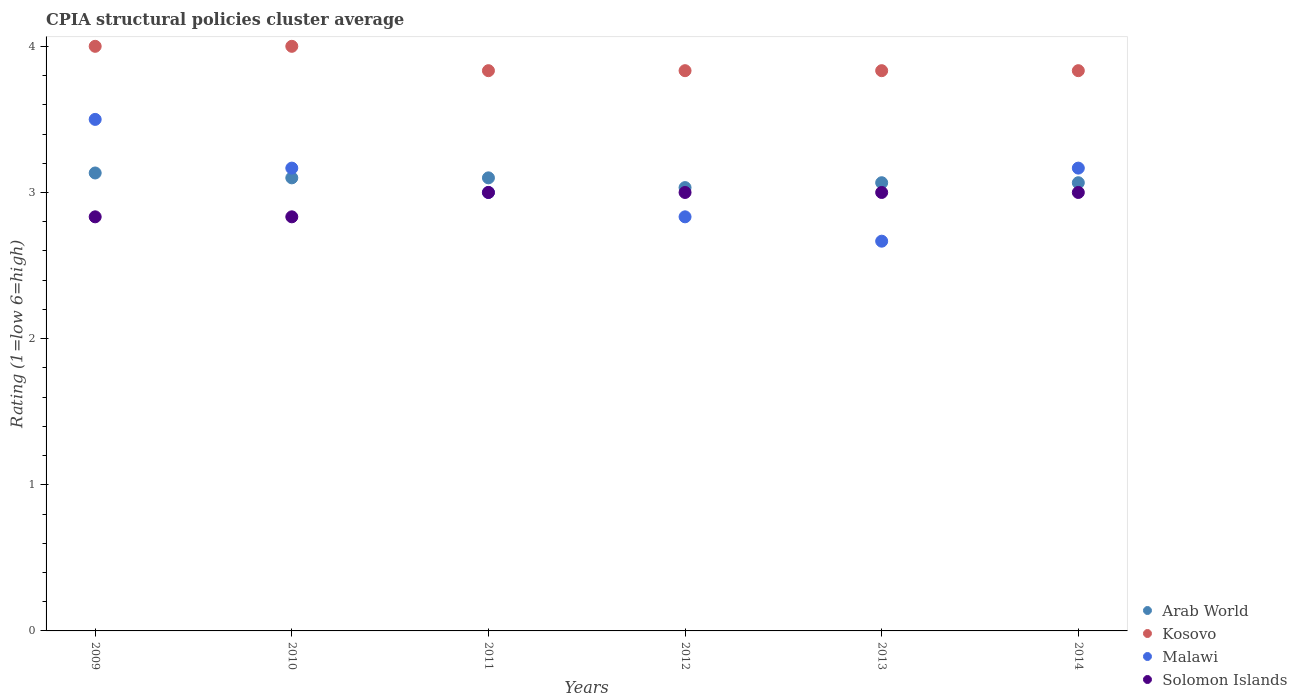How many different coloured dotlines are there?
Provide a short and direct response. 4. What is the CPIA rating in Malawi in 2013?
Make the answer very short. 2.67. Across all years, what is the maximum CPIA rating in Arab World?
Your answer should be compact. 3.13. Across all years, what is the minimum CPIA rating in Solomon Islands?
Your response must be concise. 2.83. In which year was the CPIA rating in Kosovo minimum?
Offer a terse response. 2014. What is the total CPIA rating in Solomon Islands in the graph?
Provide a succinct answer. 17.67. What is the difference between the CPIA rating in Malawi in 2010 and that in 2012?
Your answer should be compact. 0.33. What is the average CPIA rating in Kosovo per year?
Your answer should be very brief. 3.89. In how many years, is the CPIA rating in Kosovo greater than 2.6?
Make the answer very short. 6. What is the ratio of the CPIA rating in Malawi in 2011 to that in 2013?
Ensure brevity in your answer.  1.12. Is the difference between the CPIA rating in Malawi in 2010 and 2011 greater than the difference between the CPIA rating in Kosovo in 2010 and 2011?
Provide a succinct answer. No. What is the difference between the highest and the second highest CPIA rating in Kosovo?
Your answer should be very brief. 0. What is the difference between the highest and the lowest CPIA rating in Malawi?
Your response must be concise. 0.83. In how many years, is the CPIA rating in Malawi greater than the average CPIA rating in Malawi taken over all years?
Your answer should be very brief. 3. Is the sum of the CPIA rating in Malawi in 2010 and 2011 greater than the maximum CPIA rating in Kosovo across all years?
Your answer should be very brief. Yes. Is it the case that in every year, the sum of the CPIA rating in Arab World and CPIA rating in Malawi  is greater than the CPIA rating in Solomon Islands?
Offer a very short reply. Yes. Does the CPIA rating in Malawi monotonically increase over the years?
Offer a terse response. No. Is the CPIA rating in Malawi strictly greater than the CPIA rating in Kosovo over the years?
Provide a short and direct response. No. How many dotlines are there?
Your answer should be compact. 4. How many years are there in the graph?
Keep it short and to the point. 6. Are the values on the major ticks of Y-axis written in scientific E-notation?
Your response must be concise. No. Does the graph contain any zero values?
Keep it short and to the point. No. Does the graph contain grids?
Offer a very short reply. No. Where does the legend appear in the graph?
Your response must be concise. Bottom right. How are the legend labels stacked?
Ensure brevity in your answer.  Vertical. What is the title of the graph?
Your answer should be very brief. CPIA structural policies cluster average. Does "Dominica" appear as one of the legend labels in the graph?
Your response must be concise. No. What is the Rating (1=low 6=high) in Arab World in 2009?
Provide a succinct answer. 3.13. What is the Rating (1=low 6=high) of Solomon Islands in 2009?
Your answer should be very brief. 2.83. What is the Rating (1=low 6=high) in Arab World in 2010?
Keep it short and to the point. 3.1. What is the Rating (1=low 6=high) of Kosovo in 2010?
Ensure brevity in your answer.  4. What is the Rating (1=low 6=high) in Malawi in 2010?
Your response must be concise. 3.17. What is the Rating (1=low 6=high) in Solomon Islands in 2010?
Your response must be concise. 2.83. What is the Rating (1=low 6=high) in Kosovo in 2011?
Offer a terse response. 3.83. What is the Rating (1=low 6=high) of Malawi in 2011?
Ensure brevity in your answer.  3. What is the Rating (1=low 6=high) in Solomon Islands in 2011?
Provide a short and direct response. 3. What is the Rating (1=low 6=high) of Arab World in 2012?
Give a very brief answer. 3.03. What is the Rating (1=low 6=high) of Kosovo in 2012?
Make the answer very short. 3.83. What is the Rating (1=low 6=high) of Malawi in 2012?
Give a very brief answer. 2.83. What is the Rating (1=low 6=high) in Arab World in 2013?
Provide a short and direct response. 3.07. What is the Rating (1=low 6=high) of Kosovo in 2013?
Your answer should be very brief. 3.83. What is the Rating (1=low 6=high) in Malawi in 2013?
Your answer should be compact. 2.67. What is the Rating (1=low 6=high) of Solomon Islands in 2013?
Your answer should be compact. 3. What is the Rating (1=low 6=high) in Arab World in 2014?
Your answer should be very brief. 3.07. What is the Rating (1=low 6=high) in Kosovo in 2014?
Your response must be concise. 3.83. What is the Rating (1=low 6=high) of Malawi in 2014?
Your answer should be compact. 3.17. Across all years, what is the maximum Rating (1=low 6=high) of Arab World?
Offer a terse response. 3.13. Across all years, what is the minimum Rating (1=low 6=high) in Arab World?
Give a very brief answer. 3.03. Across all years, what is the minimum Rating (1=low 6=high) in Kosovo?
Your answer should be compact. 3.83. Across all years, what is the minimum Rating (1=low 6=high) of Malawi?
Ensure brevity in your answer.  2.67. Across all years, what is the minimum Rating (1=low 6=high) of Solomon Islands?
Provide a short and direct response. 2.83. What is the total Rating (1=low 6=high) of Arab World in the graph?
Your answer should be very brief. 18.5. What is the total Rating (1=low 6=high) in Kosovo in the graph?
Your answer should be very brief. 23.33. What is the total Rating (1=low 6=high) in Malawi in the graph?
Ensure brevity in your answer.  18.33. What is the total Rating (1=low 6=high) of Solomon Islands in the graph?
Keep it short and to the point. 17.67. What is the difference between the Rating (1=low 6=high) in Kosovo in 2009 and that in 2010?
Offer a terse response. 0. What is the difference between the Rating (1=low 6=high) in Malawi in 2009 and that in 2010?
Offer a terse response. 0.33. What is the difference between the Rating (1=low 6=high) in Solomon Islands in 2009 and that in 2010?
Provide a short and direct response. 0. What is the difference between the Rating (1=low 6=high) of Kosovo in 2009 and that in 2012?
Keep it short and to the point. 0.17. What is the difference between the Rating (1=low 6=high) of Malawi in 2009 and that in 2012?
Your answer should be compact. 0.67. What is the difference between the Rating (1=low 6=high) of Arab World in 2009 and that in 2013?
Your response must be concise. 0.07. What is the difference between the Rating (1=low 6=high) of Malawi in 2009 and that in 2013?
Provide a short and direct response. 0.83. What is the difference between the Rating (1=low 6=high) of Arab World in 2009 and that in 2014?
Keep it short and to the point. 0.07. What is the difference between the Rating (1=low 6=high) in Kosovo in 2009 and that in 2014?
Offer a terse response. 0.17. What is the difference between the Rating (1=low 6=high) of Solomon Islands in 2009 and that in 2014?
Your response must be concise. -0.17. What is the difference between the Rating (1=low 6=high) of Kosovo in 2010 and that in 2011?
Provide a short and direct response. 0.17. What is the difference between the Rating (1=low 6=high) in Malawi in 2010 and that in 2011?
Offer a very short reply. 0.17. What is the difference between the Rating (1=low 6=high) of Arab World in 2010 and that in 2012?
Your answer should be compact. 0.07. What is the difference between the Rating (1=low 6=high) of Malawi in 2010 and that in 2012?
Ensure brevity in your answer.  0.33. What is the difference between the Rating (1=low 6=high) of Solomon Islands in 2010 and that in 2012?
Ensure brevity in your answer.  -0.17. What is the difference between the Rating (1=low 6=high) in Arab World in 2010 and that in 2013?
Keep it short and to the point. 0.03. What is the difference between the Rating (1=low 6=high) in Solomon Islands in 2010 and that in 2013?
Offer a very short reply. -0.17. What is the difference between the Rating (1=low 6=high) in Malawi in 2010 and that in 2014?
Provide a succinct answer. -0. What is the difference between the Rating (1=low 6=high) of Solomon Islands in 2010 and that in 2014?
Offer a terse response. -0.17. What is the difference between the Rating (1=low 6=high) of Arab World in 2011 and that in 2012?
Your answer should be very brief. 0.07. What is the difference between the Rating (1=low 6=high) of Kosovo in 2011 and that in 2012?
Your answer should be compact. 0. What is the difference between the Rating (1=low 6=high) in Solomon Islands in 2011 and that in 2012?
Your answer should be compact. 0. What is the difference between the Rating (1=low 6=high) of Arab World in 2011 and that in 2013?
Your answer should be very brief. 0.03. What is the difference between the Rating (1=low 6=high) of Kosovo in 2011 and that in 2013?
Offer a very short reply. 0. What is the difference between the Rating (1=low 6=high) of Malawi in 2011 and that in 2013?
Give a very brief answer. 0.33. What is the difference between the Rating (1=low 6=high) of Solomon Islands in 2011 and that in 2013?
Provide a succinct answer. 0. What is the difference between the Rating (1=low 6=high) of Kosovo in 2011 and that in 2014?
Provide a short and direct response. 0. What is the difference between the Rating (1=low 6=high) of Arab World in 2012 and that in 2013?
Your answer should be compact. -0.03. What is the difference between the Rating (1=low 6=high) in Kosovo in 2012 and that in 2013?
Offer a terse response. 0. What is the difference between the Rating (1=low 6=high) in Malawi in 2012 and that in 2013?
Provide a short and direct response. 0.17. What is the difference between the Rating (1=low 6=high) of Arab World in 2012 and that in 2014?
Ensure brevity in your answer.  -0.03. What is the difference between the Rating (1=low 6=high) in Malawi in 2012 and that in 2014?
Offer a very short reply. -0.33. What is the difference between the Rating (1=low 6=high) in Arab World in 2013 and that in 2014?
Offer a very short reply. -0. What is the difference between the Rating (1=low 6=high) of Kosovo in 2013 and that in 2014?
Your answer should be very brief. 0. What is the difference between the Rating (1=low 6=high) in Solomon Islands in 2013 and that in 2014?
Ensure brevity in your answer.  0. What is the difference between the Rating (1=low 6=high) in Arab World in 2009 and the Rating (1=low 6=high) in Kosovo in 2010?
Your answer should be compact. -0.87. What is the difference between the Rating (1=low 6=high) in Arab World in 2009 and the Rating (1=low 6=high) in Malawi in 2010?
Make the answer very short. -0.03. What is the difference between the Rating (1=low 6=high) of Arab World in 2009 and the Rating (1=low 6=high) of Solomon Islands in 2010?
Keep it short and to the point. 0.3. What is the difference between the Rating (1=low 6=high) of Kosovo in 2009 and the Rating (1=low 6=high) of Solomon Islands in 2010?
Offer a very short reply. 1.17. What is the difference between the Rating (1=low 6=high) in Malawi in 2009 and the Rating (1=low 6=high) in Solomon Islands in 2010?
Provide a succinct answer. 0.67. What is the difference between the Rating (1=low 6=high) in Arab World in 2009 and the Rating (1=low 6=high) in Malawi in 2011?
Your answer should be compact. 0.13. What is the difference between the Rating (1=low 6=high) of Arab World in 2009 and the Rating (1=low 6=high) of Solomon Islands in 2011?
Offer a terse response. 0.13. What is the difference between the Rating (1=low 6=high) in Kosovo in 2009 and the Rating (1=low 6=high) in Malawi in 2011?
Make the answer very short. 1. What is the difference between the Rating (1=low 6=high) in Malawi in 2009 and the Rating (1=low 6=high) in Solomon Islands in 2011?
Provide a short and direct response. 0.5. What is the difference between the Rating (1=low 6=high) in Arab World in 2009 and the Rating (1=low 6=high) in Kosovo in 2012?
Ensure brevity in your answer.  -0.7. What is the difference between the Rating (1=low 6=high) in Arab World in 2009 and the Rating (1=low 6=high) in Malawi in 2012?
Provide a succinct answer. 0.3. What is the difference between the Rating (1=low 6=high) in Arab World in 2009 and the Rating (1=low 6=high) in Solomon Islands in 2012?
Provide a short and direct response. 0.13. What is the difference between the Rating (1=low 6=high) in Malawi in 2009 and the Rating (1=low 6=high) in Solomon Islands in 2012?
Your answer should be compact. 0.5. What is the difference between the Rating (1=low 6=high) of Arab World in 2009 and the Rating (1=low 6=high) of Kosovo in 2013?
Offer a terse response. -0.7. What is the difference between the Rating (1=low 6=high) of Arab World in 2009 and the Rating (1=low 6=high) of Malawi in 2013?
Your answer should be compact. 0.47. What is the difference between the Rating (1=low 6=high) in Arab World in 2009 and the Rating (1=low 6=high) in Solomon Islands in 2013?
Provide a succinct answer. 0.13. What is the difference between the Rating (1=low 6=high) of Kosovo in 2009 and the Rating (1=low 6=high) of Solomon Islands in 2013?
Your answer should be very brief. 1. What is the difference between the Rating (1=low 6=high) in Arab World in 2009 and the Rating (1=low 6=high) in Kosovo in 2014?
Your answer should be compact. -0.7. What is the difference between the Rating (1=low 6=high) in Arab World in 2009 and the Rating (1=low 6=high) in Malawi in 2014?
Ensure brevity in your answer.  -0.03. What is the difference between the Rating (1=low 6=high) of Arab World in 2009 and the Rating (1=low 6=high) of Solomon Islands in 2014?
Keep it short and to the point. 0.13. What is the difference between the Rating (1=low 6=high) of Kosovo in 2009 and the Rating (1=low 6=high) of Malawi in 2014?
Your response must be concise. 0.83. What is the difference between the Rating (1=low 6=high) of Kosovo in 2009 and the Rating (1=low 6=high) of Solomon Islands in 2014?
Your answer should be very brief. 1. What is the difference between the Rating (1=low 6=high) in Malawi in 2009 and the Rating (1=low 6=high) in Solomon Islands in 2014?
Your answer should be very brief. 0.5. What is the difference between the Rating (1=low 6=high) in Arab World in 2010 and the Rating (1=low 6=high) in Kosovo in 2011?
Offer a very short reply. -0.73. What is the difference between the Rating (1=low 6=high) in Arab World in 2010 and the Rating (1=low 6=high) in Kosovo in 2012?
Your answer should be compact. -0.73. What is the difference between the Rating (1=low 6=high) of Arab World in 2010 and the Rating (1=low 6=high) of Malawi in 2012?
Make the answer very short. 0.27. What is the difference between the Rating (1=low 6=high) of Kosovo in 2010 and the Rating (1=low 6=high) of Malawi in 2012?
Make the answer very short. 1.17. What is the difference between the Rating (1=low 6=high) of Kosovo in 2010 and the Rating (1=low 6=high) of Solomon Islands in 2012?
Offer a very short reply. 1. What is the difference between the Rating (1=low 6=high) in Arab World in 2010 and the Rating (1=low 6=high) in Kosovo in 2013?
Your response must be concise. -0.73. What is the difference between the Rating (1=low 6=high) of Arab World in 2010 and the Rating (1=low 6=high) of Malawi in 2013?
Your response must be concise. 0.43. What is the difference between the Rating (1=low 6=high) in Kosovo in 2010 and the Rating (1=low 6=high) in Solomon Islands in 2013?
Keep it short and to the point. 1. What is the difference between the Rating (1=low 6=high) of Arab World in 2010 and the Rating (1=low 6=high) of Kosovo in 2014?
Give a very brief answer. -0.73. What is the difference between the Rating (1=low 6=high) of Arab World in 2010 and the Rating (1=low 6=high) of Malawi in 2014?
Your answer should be very brief. -0.07. What is the difference between the Rating (1=low 6=high) of Kosovo in 2010 and the Rating (1=low 6=high) of Malawi in 2014?
Provide a succinct answer. 0.83. What is the difference between the Rating (1=low 6=high) of Malawi in 2010 and the Rating (1=low 6=high) of Solomon Islands in 2014?
Your response must be concise. 0.17. What is the difference between the Rating (1=low 6=high) in Arab World in 2011 and the Rating (1=low 6=high) in Kosovo in 2012?
Offer a terse response. -0.73. What is the difference between the Rating (1=low 6=high) of Arab World in 2011 and the Rating (1=low 6=high) of Malawi in 2012?
Your answer should be very brief. 0.27. What is the difference between the Rating (1=low 6=high) of Kosovo in 2011 and the Rating (1=low 6=high) of Malawi in 2012?
Provide a succinct answer. 1. What is the difference between the Rating (1=low 6=high) of Arab World in 2011 and the Rating (1=low 6=high) of Kosovo in 2013?
Keep it short and to the point. -0.73. What is the difference between the Rating (1=low 6=high) in Arab World in 2011 and the Rating (1=low 6=high) in Malawi in 2013?
Your answer should be compact. 0.43. What is the difference between the Rating (1=low 6=high) in Arab World in 2011 and the Rating (1=low 6=high) in Kosovo in 2014?
Offer a very short reply. -0.73. What is the difference between the Rating (1=low 6=high) in Arab World in 2011 and the Rating (1=low 6=high) in Malawi in 2014?
Make the answer very short. -0.07. What is the difference between the Rating (1=low 6=high) of Arab World in 2011 and the Rating (1=low 6=high) of Solomon Islands in 2014?
Provide a short and direct response. 0.1. What is the difference between the Rating (1=low 6=high) in Kosovo in 2011 and the Rating (1=low 6=high) in Malawi in 2014?
Your response must be concise. 0.67. What is the difference between the Rating (1=low 6=high) of Malawi in 2011 and the Rating (1=low 6=high) of Solomon Islands in 2014?
Provide a short and direct response. 0. What is the difference between the Rating (1=low 6=high) of Arab World in 2012 and the Rating (1=low 6=high) of Malawi in 2013?
Offer a very short reply. 0.37. What is the difference between the Rating (1=low 6=high) in Kosovo in 2012 and the Rating (1=low 6=high) in Malawi in 2013?
Make the answer very short. 1.17. What is the difference between the Rating (1=low 6=high) of Malawi in 2012 and the Rating (1=low 6=high) of Solomon Islands in 2013?
Ensure brevity in your answer.  -0.17. What is the difference between the Rating (1=low 6=high) of Arab World in 2012 and the Rating (1=low 6=high) of Malawi in 2014?
Offer a terse response. -0.13. What is the difference between the Rating (1=low 6=high) in Arab World in 2012 and the Rating (1=low 6=high) in Solomon Islands in 2014?
Give a very brief answer. 0.03. What is the difference between the Rating (1=low 6=high) of Kosovo in 2012 and the Rating (1=low 6=high) of Malawi in 2014?
Make the answer very short. 0.67. What is the difference between the Rating (1=low 6=high) of Malawi in 2012 and the Rating (1=low 6=high) of Solomon Islands in 2014?
Offer a very short reply. -0.17. What is the difference between the Rating (1=low 6=high) of Arab World in 2013 and the Rating (1=low 6=high) of Kosovo in 2014?
Your answer should be compact. -0.77. What is the difference between the Rating (1=low 6=high) in Arab World in 2013 and the Rating (1=low 6=high) in Solomon Islands in 2014?
Your answer should be compact. 0.07. What is the difference between the Rating (1=low 6=high) in Malawi in 2013 and the Rating (1=low 6=high) in Solomon Islands in 2014?
Make the answer very short. -0.33. What is the average Rating (1=low 6=high) in Arab World per year?
Ensure brevity in your answer.  3.08. What is the average Rating (1=low 6=high) in Kosovo per year?
Make the answer very short. 3.89. What is the average Rating (1=low 6=high) in Malawi per year?
Make the answer very short. 3.06. What is the average Rating (1=low 6=high) of Solomon Islands per year?
Provide a succinct answer. 2.94. In the year 2009, what is the difference between the Rating (1=low 6=high) of Arab World and Rating (1=low 6=high) of Kosovo?
Make the answer very short. -0.87. In the year 2009, what is the difference between the Rating (1=low 6=high) in Arab World and Rating (1=low 6=high) in Malawi?
Provide a succinct answer. -0.37. In the year 2009, what is the difference between the Rating (1=low 6=high) in Arab World and Rating (1=low 6=high) in Solomon Islands?
Provide a short and direct response. 0.3. In the year 2009, what is the difference between the Rating (1=low 6=high) in Kosovo and Rating (1=low 6=high) in Malawi?
Provide a succinct answer. 0.5. In the year 2009, what is the difference between the Rating (1=low 6=high) in Kosovo and Rating (1=low 6=high) in Solomon Islands?
Provide a short and direct response. 1.17. In the year 2009, what is the difference between the Rating (1=low 6=high) of Malawi and Rating (1=low 6=high) of Solomon Islands?
Offer a terse response. 0.67. In the year 2010, what is the difference between the Rating (1=low 6=high) of Arab World and Rating (1=low 6=high) of Malawi?
Provide a succinct answer. -0.07. In the year 2010, what is the difference between the Rating (1=low 6=high) in Arab World and Rating (1=low 6=high) in Solomon Islands?
Your answer should be very brief. 0.27. In the year 2010, what is the difference between the Rating (1=low 6=high) of Kosovo and Rating (1=low 6=high) of Solomon Islands?
Offer a very short reply. 1.17. In the year 2010, what is the difference between the Rating (1=low 6=high) in Malawi and Rating (1=low 6=high) in Solomon Islands?
Your answer should be compact. 0.33. In the year 2011, what is the difference between the Rating (1=low 6=high) in Arab World and Rating (1=low 6=high) in Kosovo?
Your answer should be compact. -0.73. In the year 2011, what is the difference between the Rating (1=low 6=high) of Arab World and Rating (1=low 6=high) of Malawi?
Provide a short and direct response. 0.1. In the year 2011, what is the difference between the Rating (1=low 6=high) in Arab World and Rating (1=low 6=high) in Solomon Islands?
Give a very brief answer. 0.1. In the year 2011, what is the difference between the Rating (1=low 6=high) in Kosovo and Rating (1=low 6=high) in Solomon Islands?
Your answer should be compact. 0.83. In the year 2012, what is the difference between the Rating (1=low 6=high) of Arab World and Rating (1=low 6=high) of Malawi?
Offer a very short reply. 0.2. In the year 2012, what is the difference between the Rating (1=low 6=high) of Arab World and Rating (1=low 6=high) of Solomon Islands?
Offer a very short reply. 0.03. In the year 2012, what is the difference between the Rating (1=low 6=high) of Kosovo and Rating (1=low 6=high) of Solomon Islands?
Provide a succinct answer. 0.83. In the year 2012, what is the difference between the Rating (1=low 6=high) in Malawi and Rating (1=low 6=high) in Solomon Islands?
Offer a terse response. -0.17. In the year 2013, what is the difference between the Rating (1=low 6=high) of Arab World and Rating (1=low 6=high) of Kosovo?
Make the answer very short. -0.77. In the year 2013, what is the difference between the Rating (1=low 6=high) in Arab World and Rating (1=low 6=high) in Solomon Islands?
Make the answer very short. 0.07. In the year 2013, what is the difference between the Rating (1=low 6=high) in Kosovo and Rating (1=low 6=high) in Malawi?
Keep it short and to the point. 1.17. In the year 2013, what is the difference between the Rating (1=low 6=high) in Kosovo and Rating (1=low 6=high) in Solomon Islands?
Provide a succinct answer. 0.83. In the year 2014, what is the difference between the Rating (1=low 6=high) of Arab World and Rating (1=low 6=high) of Kosovo?
Your response must be concise. -0.77. In the year 2014, what is the difference between the Rating (1=low 6=high) in Arab World and Rating (1=low 6=high) in Malawi?
Provide a succinct answer. -0.1. In the year 2014, what is the difference between the Rating (1=low 6=high) of Arab World and Rating (1=low 6=high) of Solomon Islands?
Give a very brief answer. 0.07. In the year 2014, what is the difference between the Rating (1=low 6=high) in Malawi and Rating (1=low 6=high) in Solomon Islands?
Offer a very short reply. 0.17. What is the ratio of the Rating (1=low 6=high) of Arab World in 2009 to that in 2010?
Provide a short and direct response. 1.01. What is the ratio of the Rating (1=low 6=high) in Kosovo in 2009 to that in 2010?
Provide a short and direct response. 1. What is the ratio of the Rating (1=low 6=high) in Malawi in 2009 to that in 2010?
Make the answer very short. 1.11. What is the ratio of the Rating (1=low 6=high) of Arab World in 2009 to that in 2011?
Make the answer very short. 1.01. What is the ratio of the Rating (1=low 6=high) of Kosovo in 2009 to that in 2011?
Ensure brevity in your answer.  1.04. What is the ratio of the Rating (1=low 6=high) in Malawi in 2009 to that in 2011?
Offer a terse response. 1.17. What is the ratio of the Rating (1=low 6=high) of Solomon Islands in 2009 to that in 2011?
Make the answer very short. 0.94. What is the ratio of the Rating (1=low 6=high) of Arab World in 2009 to that in 2012?
Your response must be concise. 1.03. What is the ratio of the Rating (1=low 6=high) in Kosovo in 2009 to that in 2012?
Provide a short and direct response. 1.04. What is the ratio of the Rating (1=low 6=high) in Malawi in 2009 to that in 2012?
Provide a short and direct response. 1.24. What is the ratio of the Rating (1=low 6=high) of Arab World in 2009 to that in 2013?
Ensure brevity in your answer.  1.02. What is the ratio of the Rating (1=low 6=high) of Kosovo in 2009 to that in 2013?
Keep it short and to the point. 1.04. What is the ratio of the Rating (1=low 6=high) in Malawi in 2009 to that in 2013?
Offer a terse response. 1.31. What is the ratio of the Rating (1=low 6=high) of Solomon Islands in 2009 to that in 2013?
Offer a terse response. 0.94. What is the ratio of the Rating (1=low 6=high) of Arab World in 2009 to that in 2014?
Your response must be concise. 1.02. What is the ratio of the Rating (1=low 6=high) in Kosovo in 2009 to that in 2014?
Provide a succinct answer. 1.04. What is the ratio of the Rating (1=low 6=high) in Malawi in 2009 to that in 2014?
Your answer should be compact. 1.11. What is the ratio of the Rating (1=low 6=high) in Solomon Islands in 2009 to that in 2014?
Provide a short and direct response. 0.94. What is the ratio of the Rating (1=low 6=high) in Kosovo in 2010 to that in 2011?
Offer a terse response. 1.04. What is the ratio of the Rating (1=low 6=high) of Malawi in 2010 to that in 2011?
Provide a short and direct response. 1.06. What is the ratio of the Rating (1=low 6=high) of Solomon Islands in 2010 to that in 2011?
Make the answer very short. 0.94. What is the ratio of the Rating (1=low 6=high) in Arab World in 2010 to that in 2012?
Ensure brevity in your answer.  1.02. What is the ratio of the Rating (1=low 6=high) of Kosovo in 2010 to that in 2012?
Offer a terse response. 1.04. What is the ratio of the Rating (1=low 6=high) in Malawi in 2010 to that in 2012?
Keep it short and to the point. 1.12. What is the ratio of the Rating (1=low 6=high) of Arab World in 2010 to that in 2013?
Provide a succinct answer. 1.01. What is the ratio of the Rating (1=low 6=high) in Kosovo in 2010 to that in 2013?
Your answer should be very brief. 1.04. What is the ratio of the Rating (1=low 6=high) in Malawi in 2010 to that in 2013?
Your answer should be compact. 1.19. What is the ratio of the Rating (1=low 6=high) in Solomon Islands in 2010 to that in 2013?
Keep it short and to the point. 0.94. What is the ratio of the Rating (1=low 6=high) in Arab World in 2010 to that in 2014?
Provide a succinct answer. 1.01. What is the ratio of the Rating (1=low 6=high) of Kosovo in 2010 to that in 2014?
Keep it short and to the point. 1.04. What is the ratio of the Rating (1=low 6=high) of Solomon Islands in 2010 to that in 2014?
Offer a terse response. 0.94. What is the ratio of the Rating (1=low 6=high) in Kosovo in 2011 to that in 2012?
Your response must be concise. 1. What is the ratio of the Rating (1=low 6=high) of Malawi in 2011 to that in 2012?
Give a very brief answer. 1.06. What is the ratio of the Rating (1=low 6=high) in Solomon Islands in 2011 to that in 2012?
Provide a succinct answer. 1. What is the ratio of the Rating (1=low 6=high) of Arab World in 2011 to that in 2013?
Give a very brief answer. 1.01. What is the ratio of the Rating (1=low 6=high) in Arab World in 2011 to that in 2014?
Make the answer very short. 1.01. What is the ratio of the Rating (1=low 6=high) of Kosovo in 2011 to that in 2014?
Your answer should be compact. 1. What is the ratio of the Rating (1=low 6=high) in Malawi in 2011 to that in 2014?
Your answer should be compact. 0.95. What is the ratio of the Rating (1=low 6=high) in Arab World in 2012 to that in 2014?
Your answer should be compact. 0.99. What is the ratio of the Rating (1=low 6=high) in Kosovo in 2012 to that in 2014?
Provide a short and direct response. 1. What is the ratio of the Rating (1=low 6=high) in Malawi in 2012 to that in 2014?
Offer a very short reply. 0.89. What is the ratio of the Rating (1=low 6=high) of Arab World in 2013 to that in 2014?
Provide a short and direct response. 1. What is the ratio of the Rating (1=low 6=high) in Kosovo in 2013 to that in 2014?
Your answer should be very brief. 1. What is the ratio of the Rating (1=low 6=high) in Malawi in 2013 to that in 2014?
Offer a terse response. 0.84. What is the difference between the highest and the second highest Rating (1=low 6=high) of Solomon Islands?
Your answer should be compact. 0. What is the difference between the highest and the lowest Rating (1=low 6=high) in Arab World?
Your answer should be very brief. 0.1. What is the difference between the highest and the lowest Rating (1=low 6=high) of Kosovo?
Your answer should be very brief. 0.17. 